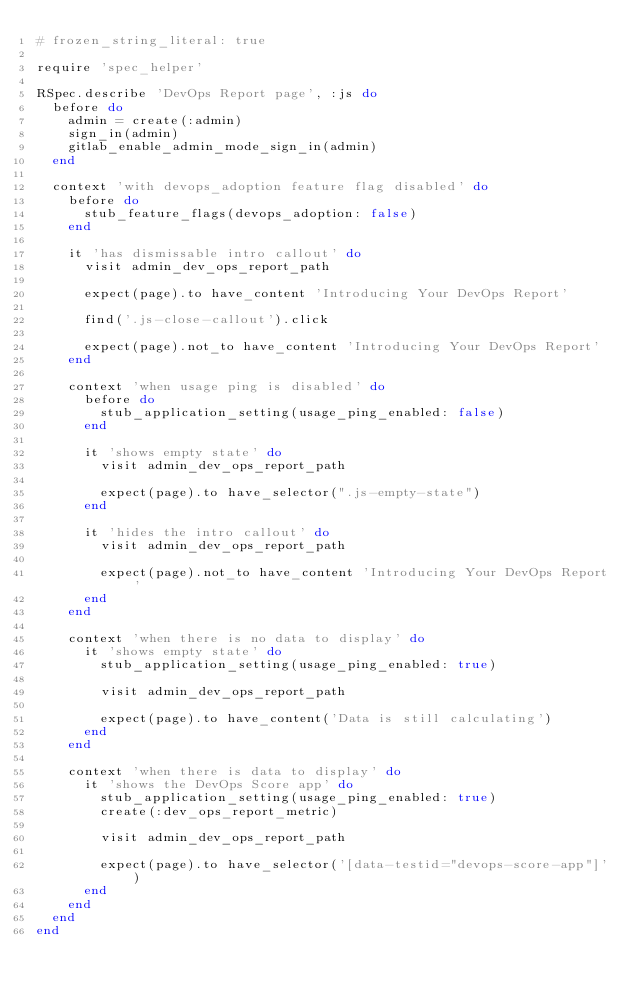Convert code to text. <code><loc_0><loc_0><loc_500><loc_500><_Ruby_># frozen_string_literal: true

require 'spec_helper'

RSpec.describe 'DevOps Report page', :js do
  before do
    admin = create(:admin)
    sign_in(admin)
    gitlab_enable_admin_mode_sign_in(admin)
  end

  context 'with devops_adoption feature flag disabled' do
    before do
      stub_feature_flags(devops_adoption: false)
    end

    it 'has dismissable intro callout' do
      visit admin_dev_ops_report_path

      expect(page).to have_content 'Introducing Your DevOps Report'

      find('.js-close-callout').click

      expect(page).not_to have_content 'Introducing Your DevOps Report'
    end

    context 'when usage ping is disabled' do
      before do
        stub_application_setting(usage_ping_enabled: false)
      end

      it 'shows empty state' do
        visit admin_dev_ops_report_path

        expect(page).to have_selector(".js-empty-state")
      end

      it 'hides the intro callout' do
        visit admin_dev_ops_report_path

        expect(page).not_to have_content 'Introducing Your DevOps Report'
      end
    end

    context 'when there is no data to display' do
      it 'shows empty state' do
        stub_application_setting(usage_ping_enabled: true)

        visit admin_dev_ops_report_path

        expect(page).to have_content('Data is still calculating')
      end
    end

    context 'when there is data to display' do
      it 'shows the DevOps Score app' do
        stub_application_setting(usage_ping_enabled: true)
        create(:dev_ops_report_metric)

        visit admin_dev_ops_report_path

        expect(page).to have_selector('[data-testid="devops-score-app"]')
      end
    end
  end
end
</code> 